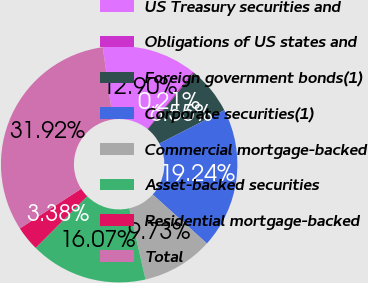Convert chart to OTSL. <chart><loc_0><loc_0><loc_500><loc_500><pie_chart><fcel>US Treasury securities and<fcel>Obligations of US states and<fcel>Foreign government bonds(1)<fcel>Corporate securities(1)<fcel>Commercial mortgage-backed<fcel>Asset-backed securities<fcel>Residential mortgage-backed<fcel>Total<nl><fcel>12.9%<fcel>0.21%<fcel>6.55%<fcel>19.24%<fcel>9.73%<fcel>16.07%<fcel>3.38%<fcel>31.92%<nl></chart> 